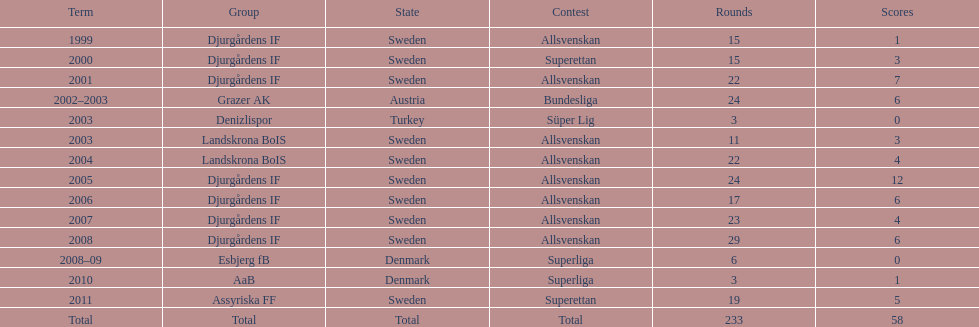How many matches overall were there? 233. 